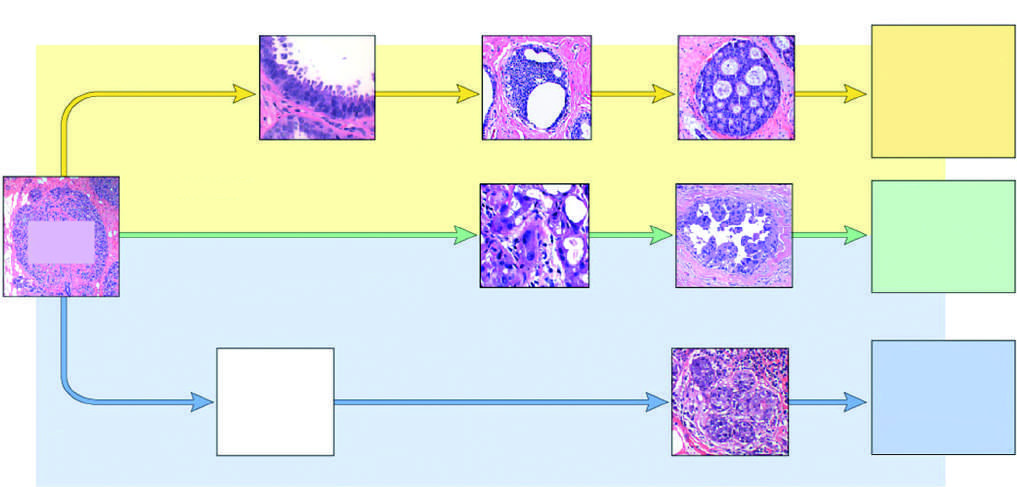what is the least common but molecularly most distinctive type of breast cancer?
Answer the question using a single word or phrase. Negative for er and her2 